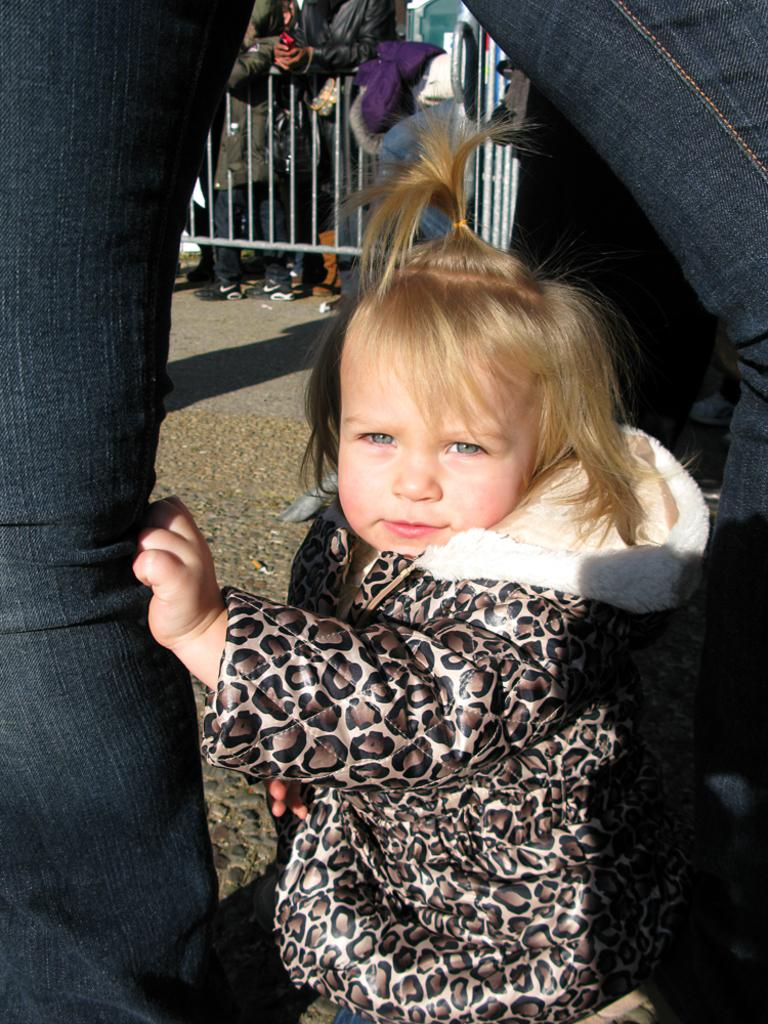How many people are in the image? The number of people in the image cannot be determined from the provided facts. What is the purpose of the barrier in the image? The purpose of the barrier in the image cannot be determined from the provided facts. What type of steel is used to construct the oil rod in the image? There is no steel, oil, or rod present in the image. 